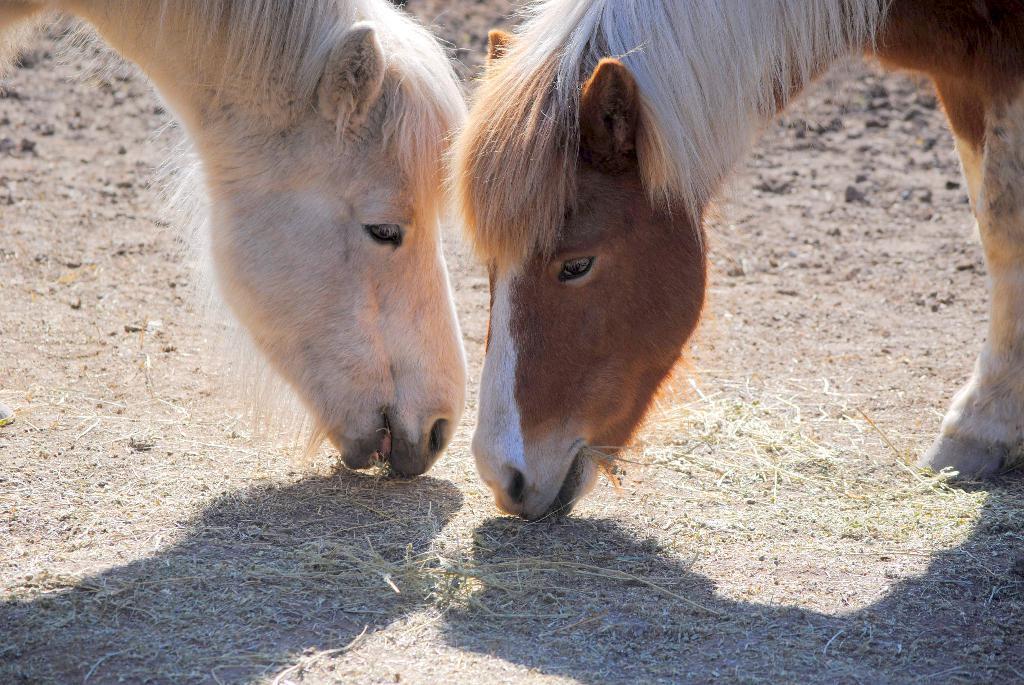In one or two sentences, can you explain what this image depicts? In this image I can see two animals eating grass, the animals are in brown and white color. 